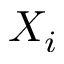<formula> <loc_0><loc_0><loc_500><loc_500>X _ { i }</formula> 